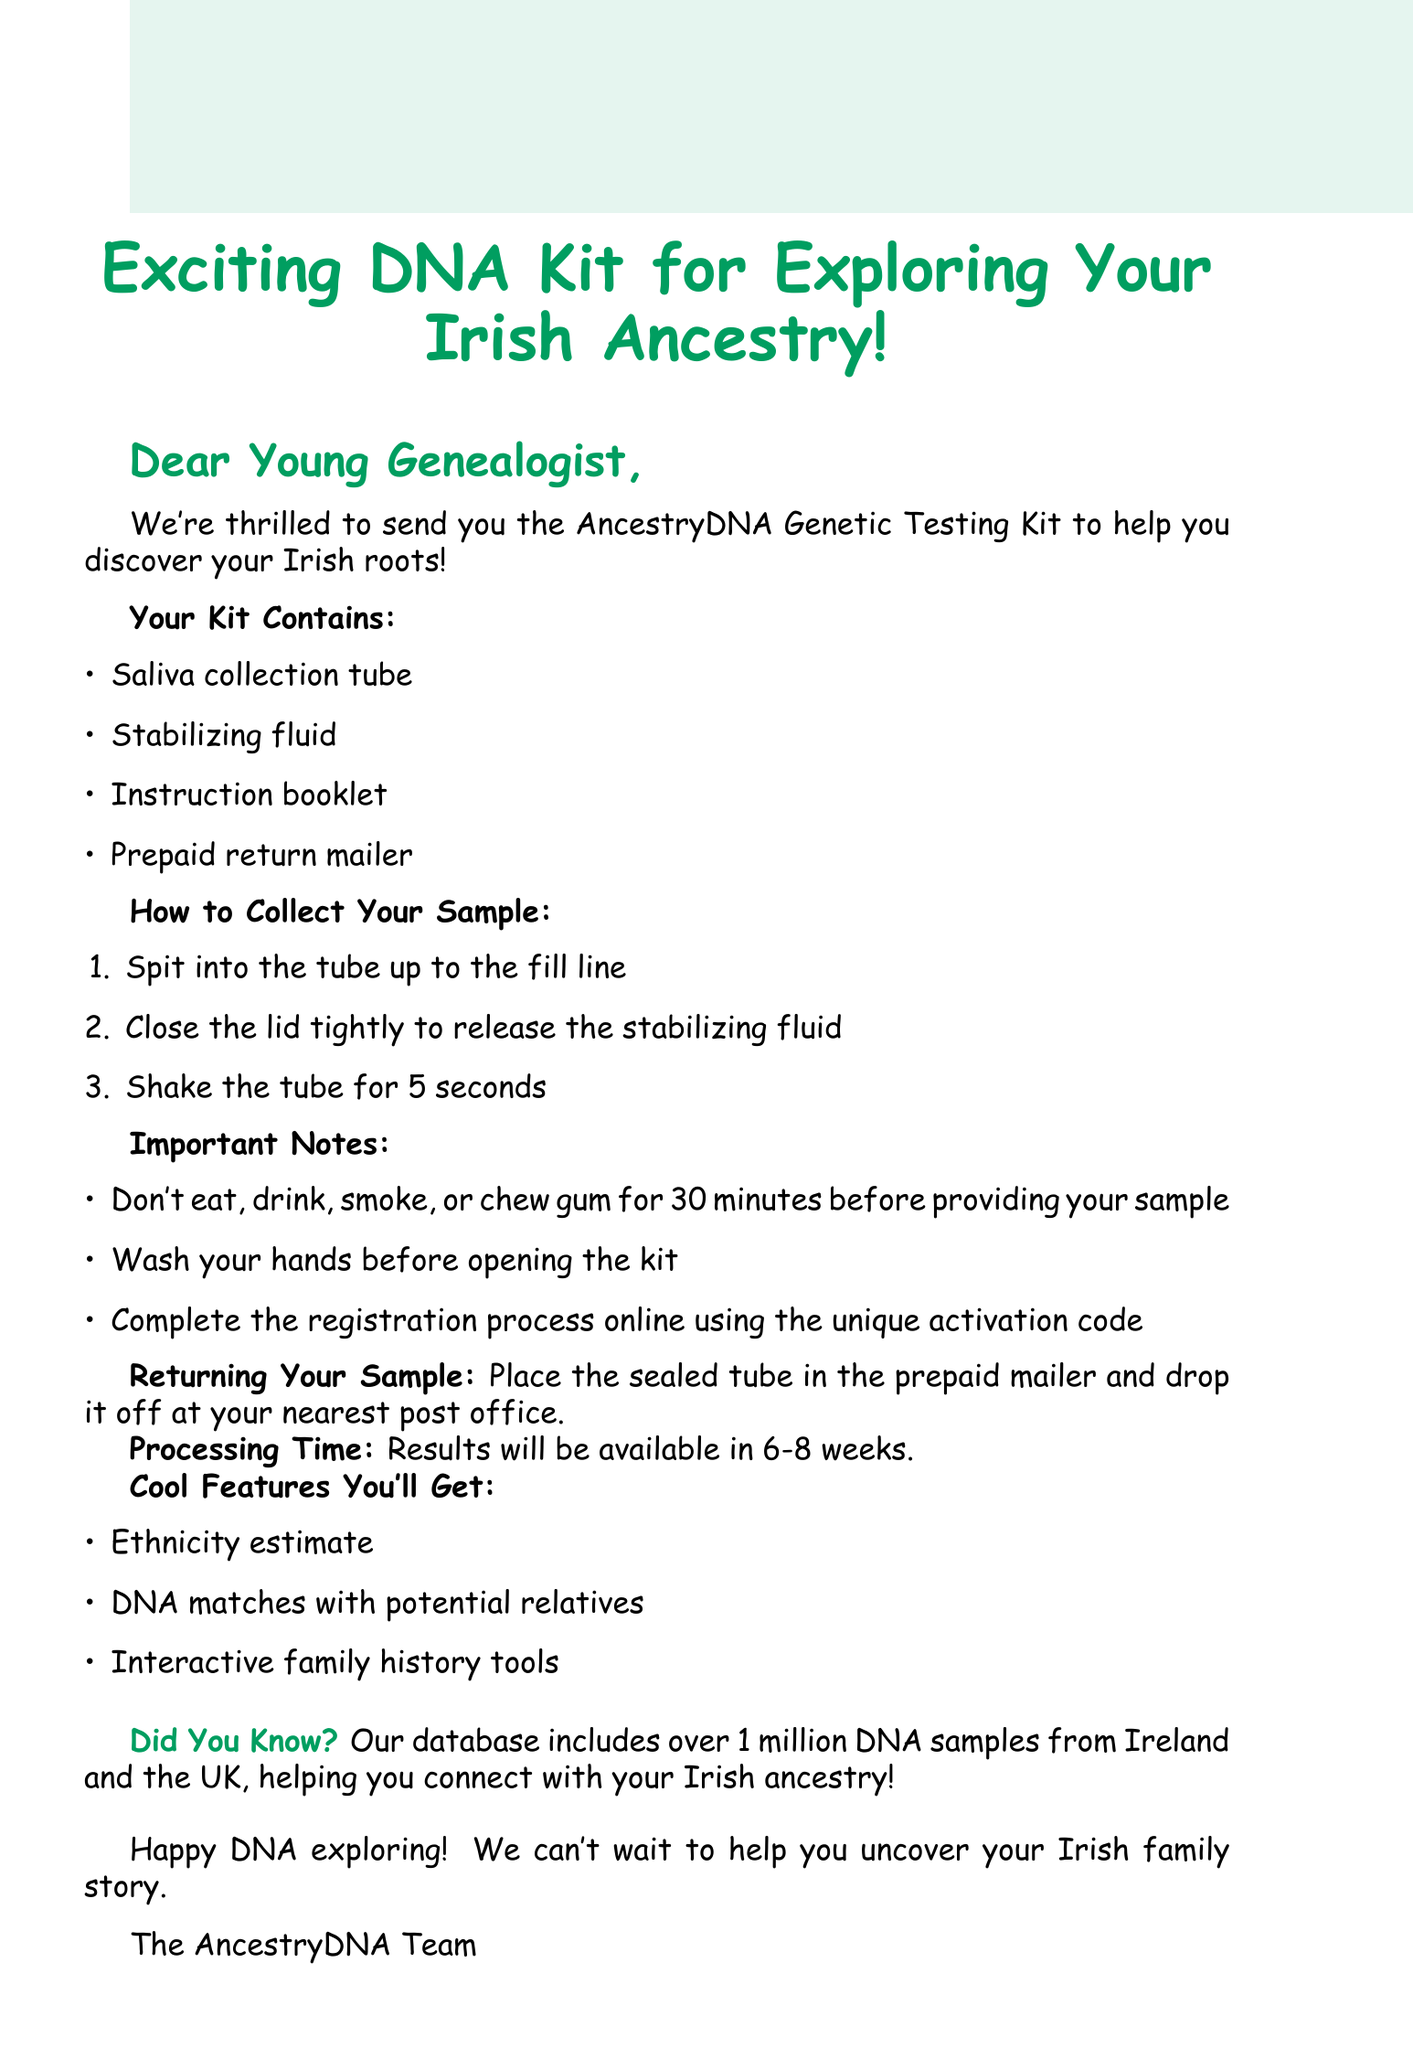what is the subject of the mail? The subject of the mail is clearly stated at the beginning as the title of the document.
Answer: Exciting DNA Kit for Exploring Your Irish Ancestry! what items are included in the kit? The document lists the contents of the kit in a bullet format, providing specific items.
Answer: Saliva collection tube, Stabilizing fluid, Instruction booklet, Prepaid return mailer what is the first step in collecting your sample? The steps to collect the sample are numbered, and the first instruction is given directly.
Answer: Spit into the tube up to the fill line what should you not do 30 minutes before providing your sample? The document emphasizes important notes about preparing for the sample collection.
Answer: Don't eat, drink, smoke, or chew gum how long will it take to get results? The processing time for the results is mentioned in the document, providing a specific timeframe.
Answer: 6-8 weeks what unique feature will the DNA testing reveal? The document highlights the cool features of the DNA test, focusing on one of the capabilities it offers.
Answer: Ethnicity estimate how many DNA samples are in the database from Ireland and the UK? A specific number is mentioned in relation to the database, indicating its size.
Answer: Over 1 million what must you do before opening the kit? The important notes section specifies a preparatory action for the user before they start.
Answer: Wash your hands 